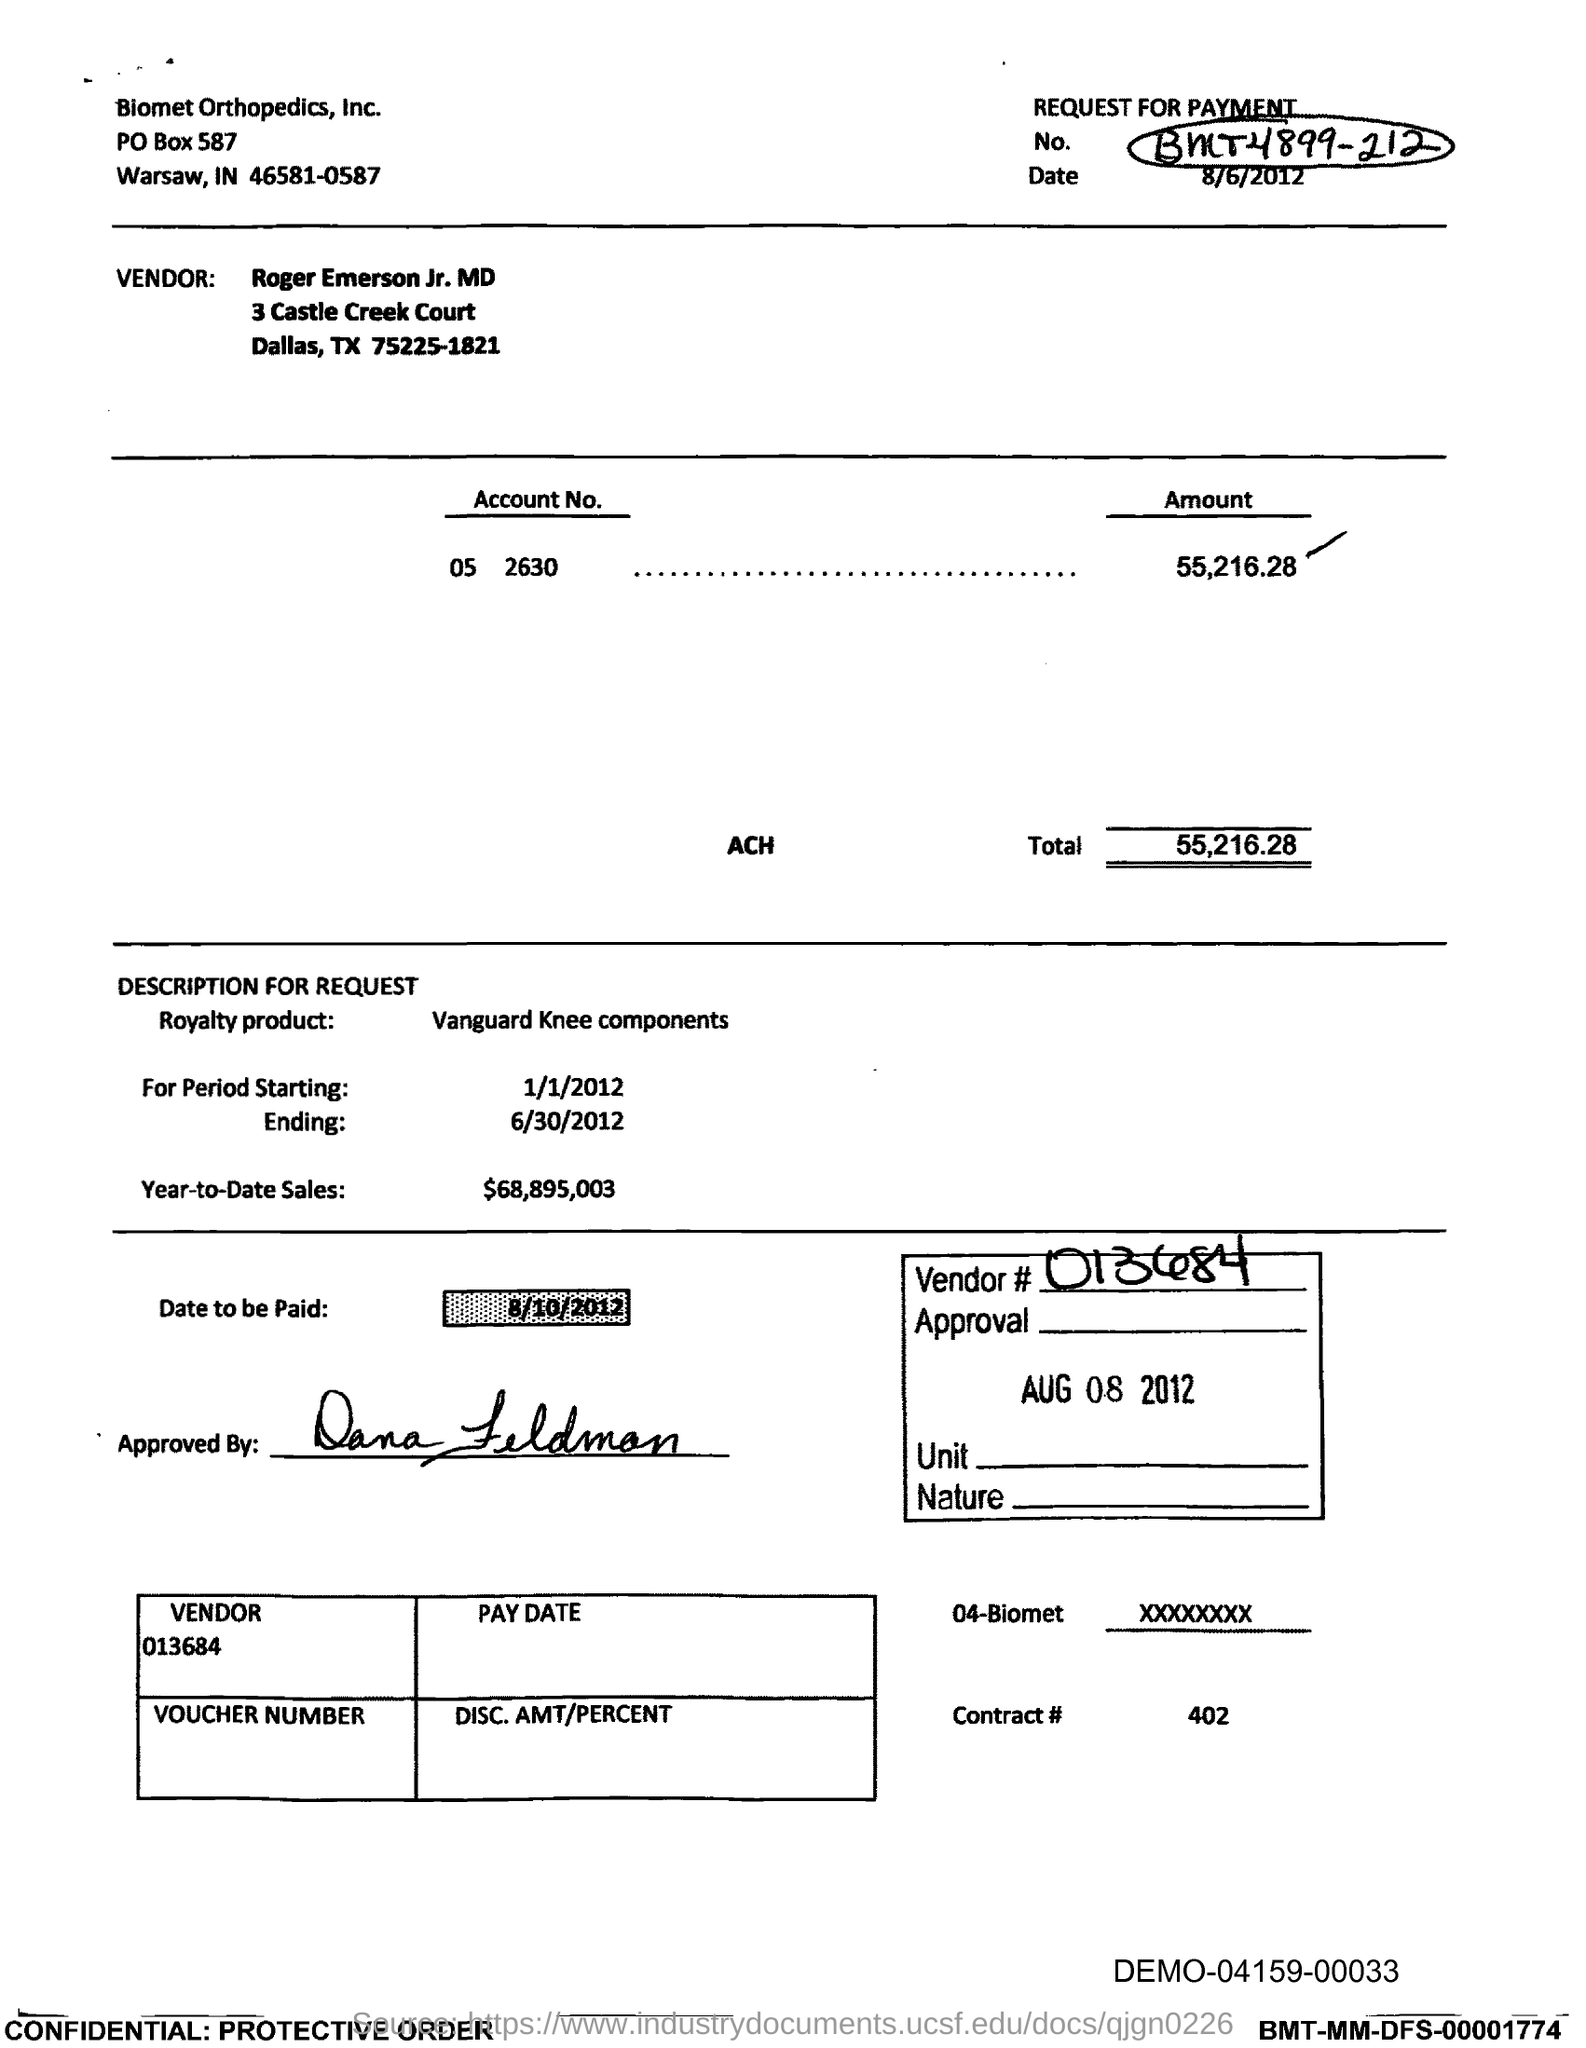What is the Amount?
Keep it short and to the point. 55,216.28. What is the Total?
Offer a terse response. 55,216.28. What is the starting period?
Your response must be concise. 1/1/2012. What is the ending period?
Offer a terse response. 6/30/2012. What is the Year-to-date sales?
Offer a terse response. 68,895,003. When is the date to be paid?
Give a very brief answer. 8/10/2012. What is the Vendor number?
Provide a short and direct response. 013684. When is the approval?
Your answer should be compact. AUG 08 2012. 